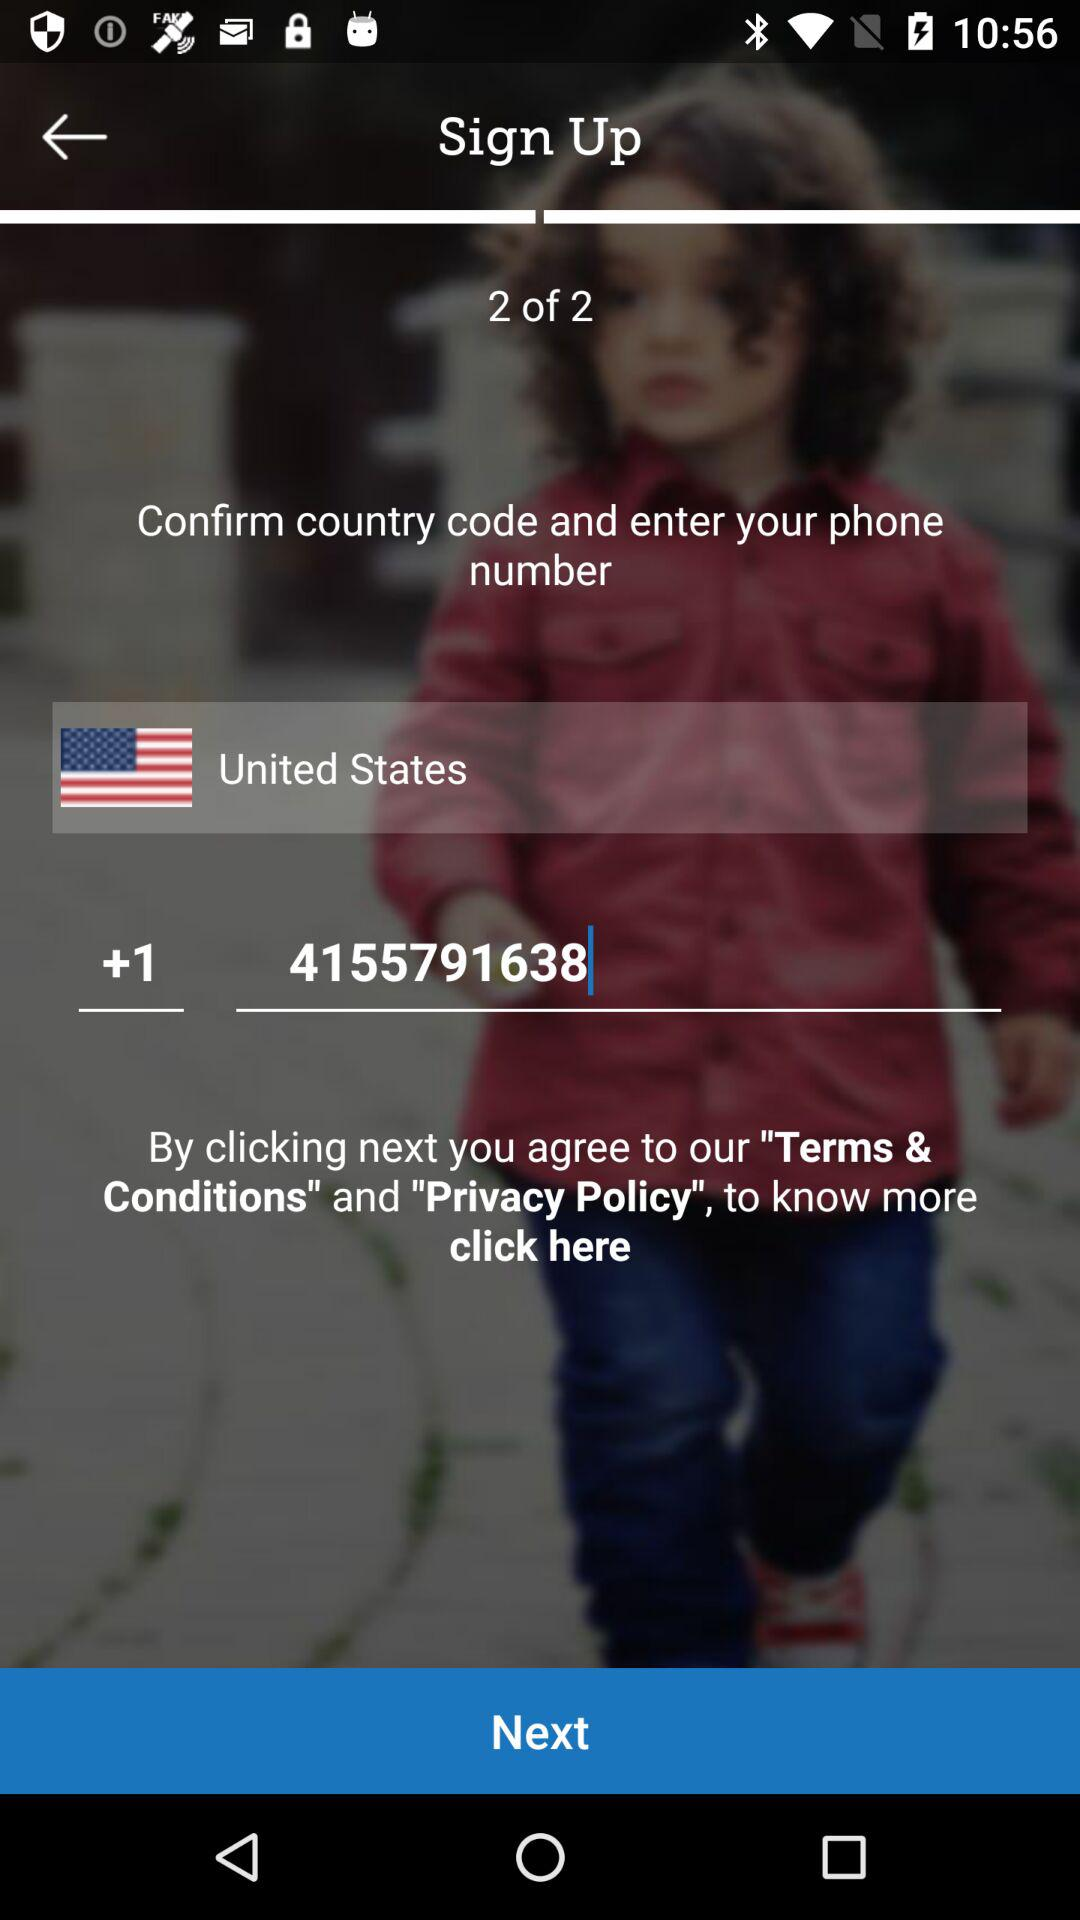How many sets are available? There are 2 sets available. 